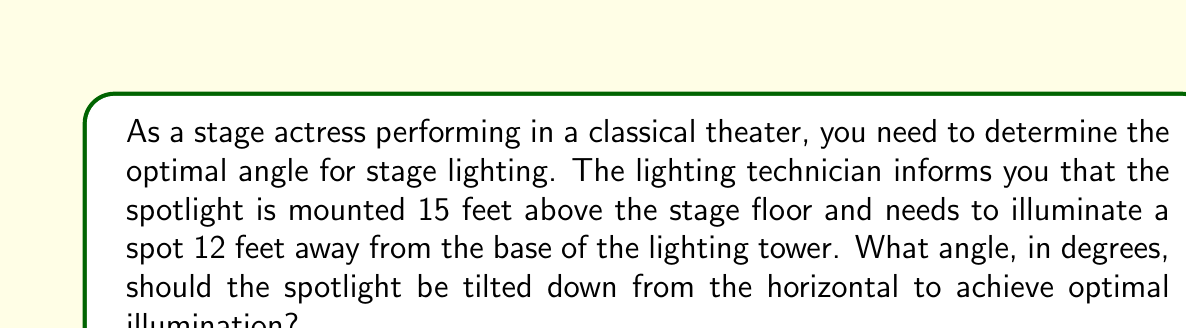Give your solution to this math problem. Let's approach this step-by-step using trigonometry:

1) We can visualize this scenario as a right triangle, where:
   - The height of the spotlight is the opposite side (15 feet)
   - The distance on the stage floor is the adjacent side (12 feet)
   - The angle we're looking for is the one between the horizontal and the light beam

2) In this right triangle, we need to find the angle given the opposite and adjacent sides. This calls for the arctangent function.

3) The tangent of an angle is defined as the ratio of the opposite side to the adjacent side:

   $$\tan(\theta) = \frac{\text{opposite}}{\text{adjacent}}$$

4) Substituting our values:

   $$\tan(\theta) = \frac{15}{12}$$

5) To find the angle, we need to take the inverse tangent (arctangent) of both sides:

   $$\theta = \arctan(\frac{15}{12})$$

6) Using a calculator or computer:

   $$\theta \approx 51.34°$$

7) Round to two decimal places for practical use in stage lighting.
Answer: $51.34°$ 